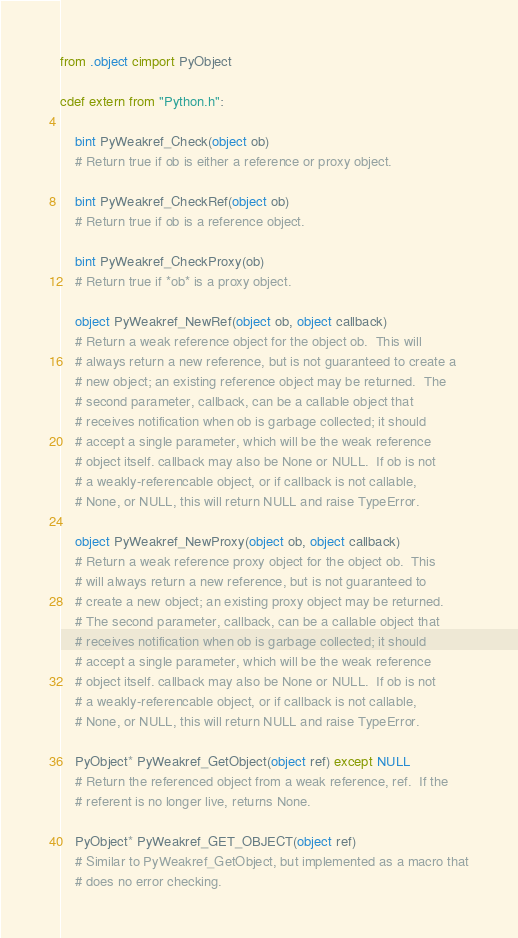<code> <loc_0><loc_0><loc_500><loc_500><_Cython_>from .object cimport PyObject

cdef extern from "Python.h":

    bint PyWeakref_Check(object ob)
    # Return true if ob is either a reference or proxy object.

    bint PyWeakref_CheckRef(object ob)
    # Return true if ob is a reference object.

    bint PyWeakref_CheckProxy(ob)
    # Return true if *ob* is a proxy object.

    object PyWeakref_NewRef(object ob, object callback)
    # Return a weak reference object for the object ob.  This will
    # always return a new reference, but is not guaranteed to create a
    # new object; an existing reference object may be returned.  The
    # second parameter, callback, can be a callable object that
    # receives notification when ob is garbage collected; it should
    # accept a single parameter, which will be the weak reference
    # object itself. callback may also be None or NULL.  If ob is not
    # a weakly-referencable object, or if callback is not callable,
    # None, or NULL, this will return NULL and raise TypeError.

    object PyWeakref_NewProxy(object ob, object callback)
    # Return a weak reference proxy object for the object ob.  This
    # will always return a new reference, but is not guaranteed to
    # create a new object; an existing proxy object may be returned.
    # The second parameter, callback, can be a callable object that
    # receives notification when ob is garbage collected; it should
    # accept a single parameter, which will be the weak reference
    # object itself. callback may also be None or NULL.  If ob is not
    # a weakly-referencable object, or if callback is not callable,
    # None, or NULL, this will return NULL and raise TypeError.

    PyObject* PyWeakref_GetObject(object ref) except NULL
    # Return the referenced object from a weak reference, ref.  If the
    # referent is no longer live, returns None.

    PyObject* PyWeakref_GET_OBJECT(object ref)
    # Similar to PyWeakref_GetObject, but implemented as a macro that
    # does no error checking.
</code> 